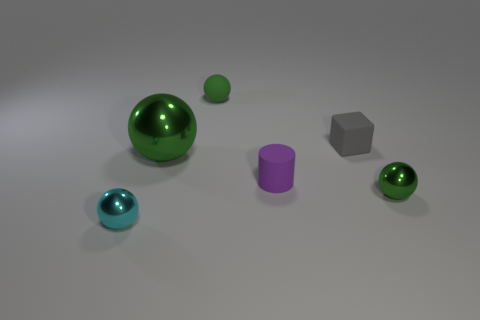Is there anything else that has the same shape as the purple rubber object?
Keep it short and to the point. No. Are the small cube and the tiny ball behind the large shiny object made of the same material?
Offer a very short reply. Yes. Is the shape of the tiny matte thing right of the purple thing the same as  the purple thing?
Ensure brevity in your answer.  No. There is a large thing that is the same shape as the tiny cyan object; what is it made of?
Your answer should be compact. Metal. There is a big metallic thing; does it have the same shape as the shiny object that is to the right of the small purple matte object?
Make the answer very short. Yes. What is the color of the metallic sphere that is on the left side of the green matte ball and in front of the large thing?
Provide a succinct answer. Cyan. Are there any cyan spheres?
Your response must be concise. Yes. Are there the same number of purple matte cylinders in front of the small cyan sphere and small matte blocks?
Your answer should be compact. No. What number of other things are there of the same shape as the gray rubber thing?
Offer a very short reply. 0. What shape is the big green thing?
Give a very brief answer. Sphere. 